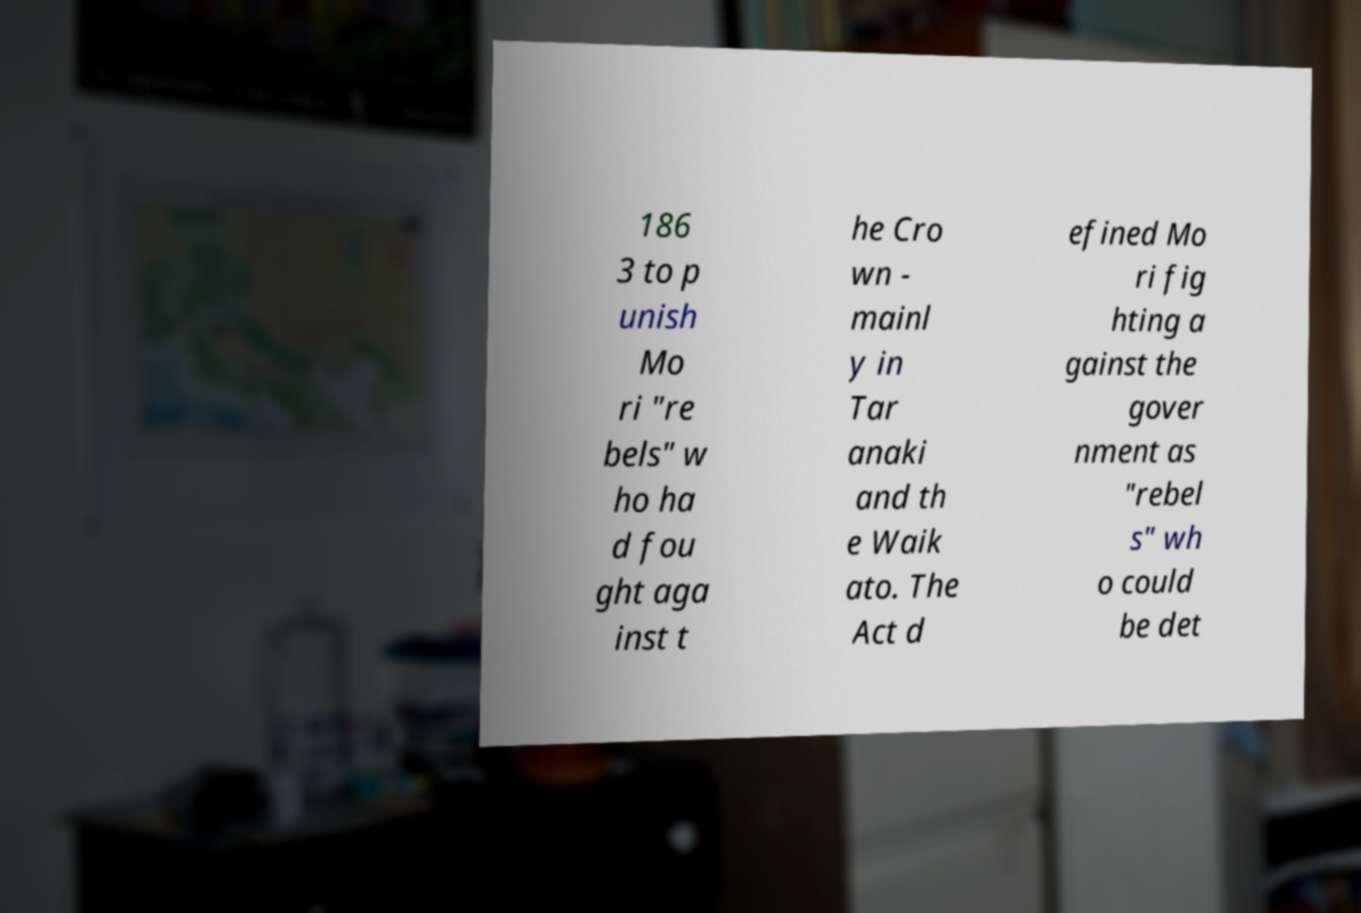Could you assist in decoding the text presented in this image and type it out clearly? 186 3 to p unish Mo ri "re bels" w ho ha d fou ght aga inst t he Cro wn - mainl y in Tar anaki and th e Waik ato. The Act d efined Mo ri fig hting a gainst the gover nment as "rebel s" wh o could be det 